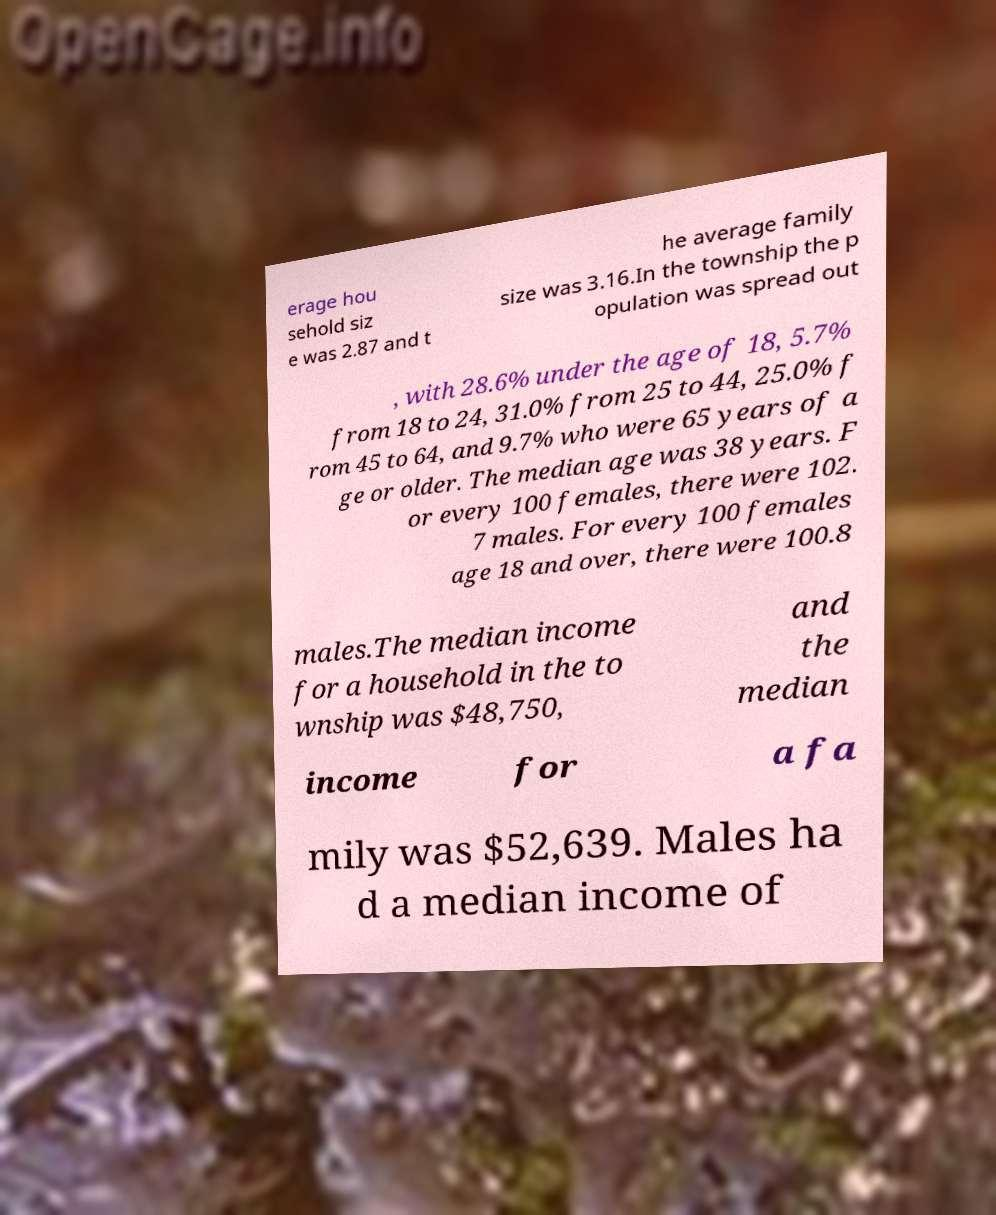For documentation purposes, I need the text within this image transcribed. Could you provide that? erage hou sehold siz e was 2.87 and t he average family size was 3.16.In the township the p opulation was spread out , with 28.6% under the age of 18, 5.7% from 18 to 24, 31.0% from 25 to 44, 25.0% f rom 45 to 64, and 9.7% who were 65 years of a ge or older. The median age was 38 years. F or every 100 females, there were 102. 7 males. For every 100 females age 18 and over, there were 100.8 males.The median income for a household in the to wnship was $48,750, and the median income for a fa mily was $52,639. Males ha d a median income of 